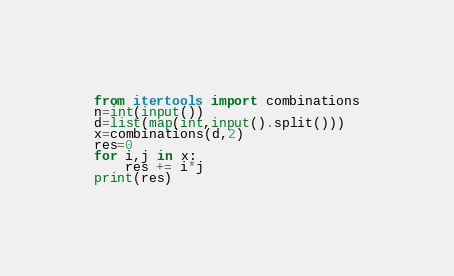Convert code to text. <code><loc_0><loc_0><loc_500><loc_500><_Python_>from itertools import combinations
n=int(input())
d=list(map(int,input().split()))
x=combinations(d,2)
res=0
for i,j in x:
	res += i*j
print(res)</code> 